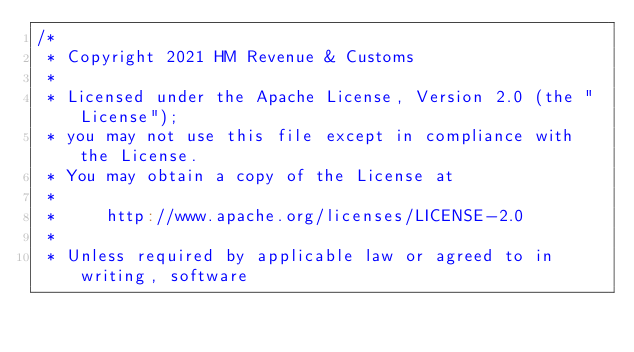<code> <loc_0><loc_0><loc_500><loc_500><_Scala_>/*
 * Copyright 2021 HM Revenue & Customs
 *
 * Licensed under the Apache License, Version 2.0 (the "License");
 * you may not use this file except in compliance with the License.
 * You may obtain a copy of the License at
 *
 *     http://www.apache.org/licenses/LICENSE-2.0
 *
 * Unless required by applicable law or agreed to in writing, software</code> 